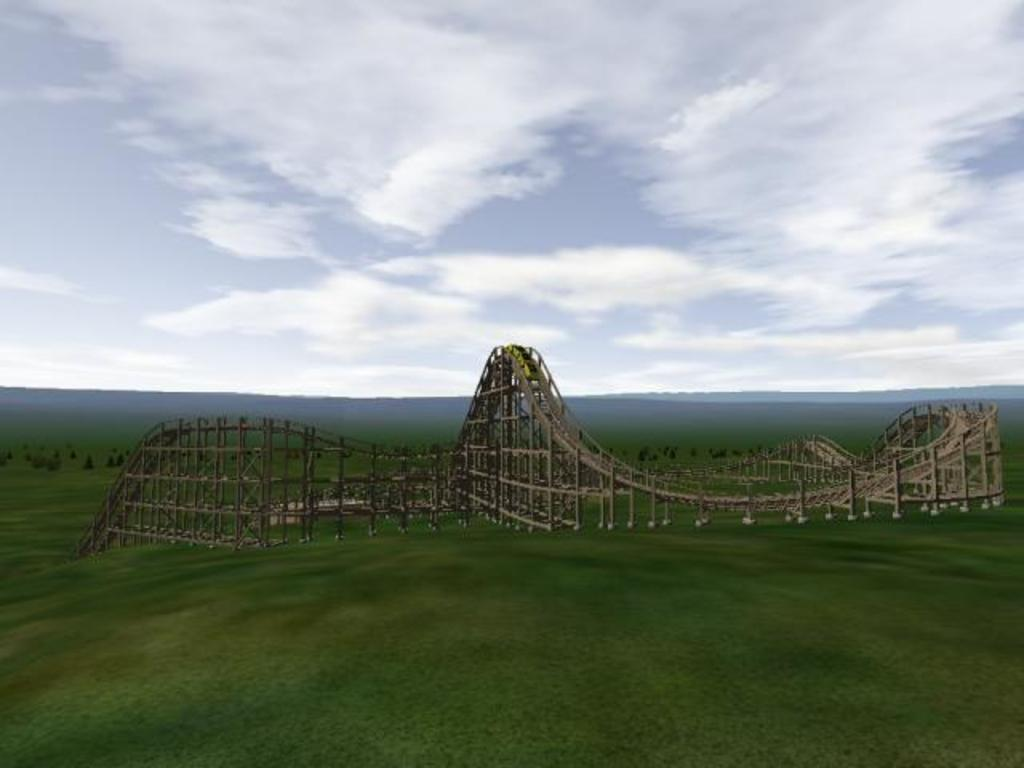What is the main subject of the animated picture in the image? The main subject of the animated picture is a roller coaster ramp. What can be seen in the background of the image? The sky is visible in the background of the image. How would you describe the weather based on the appearance of the sky? The sky appears to be cloudy, which might suggest overcast or potentially rainy weather. Where is the fire hydrant located in the image? There is no fire hydrant present in the image. What is the process for riding the roller coaster in the image? The image is an animated picture, so it does not show a real-life roller coaster or the process for riding it. 